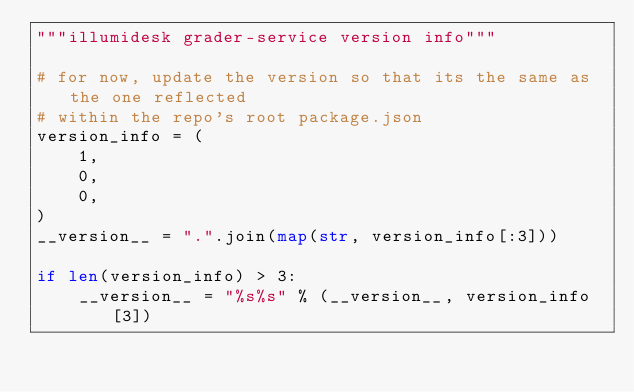Convert code to text. <code><loc_0><loc_0><loc_500><loc_500><_Python_>"""illumidesk grader-service version info"""

# for now, update the version so that its the same as the one reflected
# within the repo's root package.json
version_info = (
    1,
    0,
    0,
)
__version__ = ".".join(map(str, version_info[:3]))

if len(version_info) > 3:
    __version__ = "%s%s" % (__version__, version_info[3])
</code> 